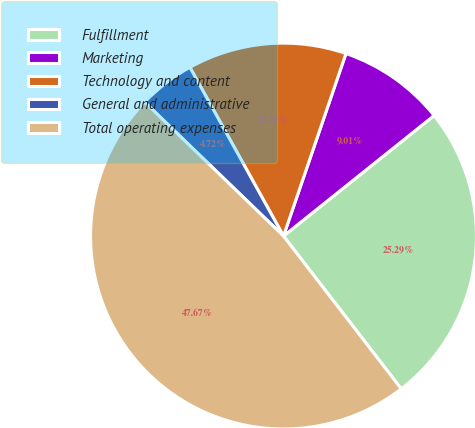Convert chart to OTSL. <chart><loc_0><loc_0><loc_500><loc_500><pie_chart><fcel>Fulfillment<fcel>Marketing<fcel>Technology and content<fcel>General and administrative<fcel>Total operating expenses<nl><fcel>25.29%<fcel>9.01%<fcel>13.31%<fcel>4.72%<fcel>47.67%<nl></chart> 